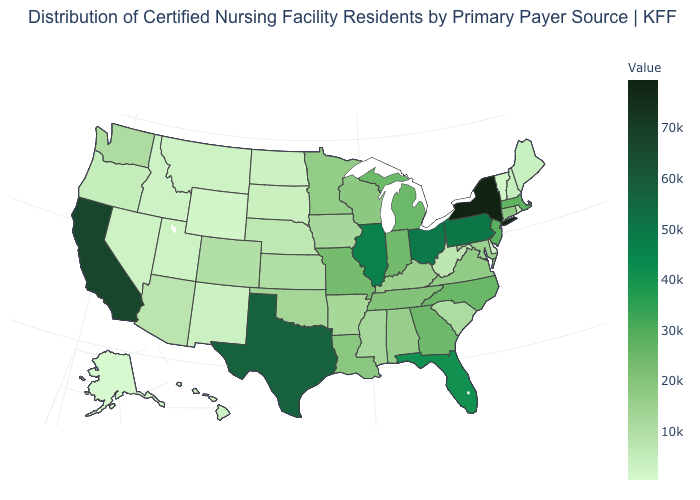Which states hav the highest value in the MidWest?
Be succinct. Ohio. Is the legend a continuous bar?
Give a very brief answer. Yes. Does Delaware have the lowest value in the South?
Write a very short answer. Yes. Does Pennsylvania have the lowest value in the Northeast?
Give a very brief answer. No. Among the states that border Delaware , does Maryland have the highest value?
Concise answer only. No. Which states have the lowest value in the USA?
Give a very brief answer. Alaska. Does New York have the highest value in the USA?
Concise answer only. Yes. 